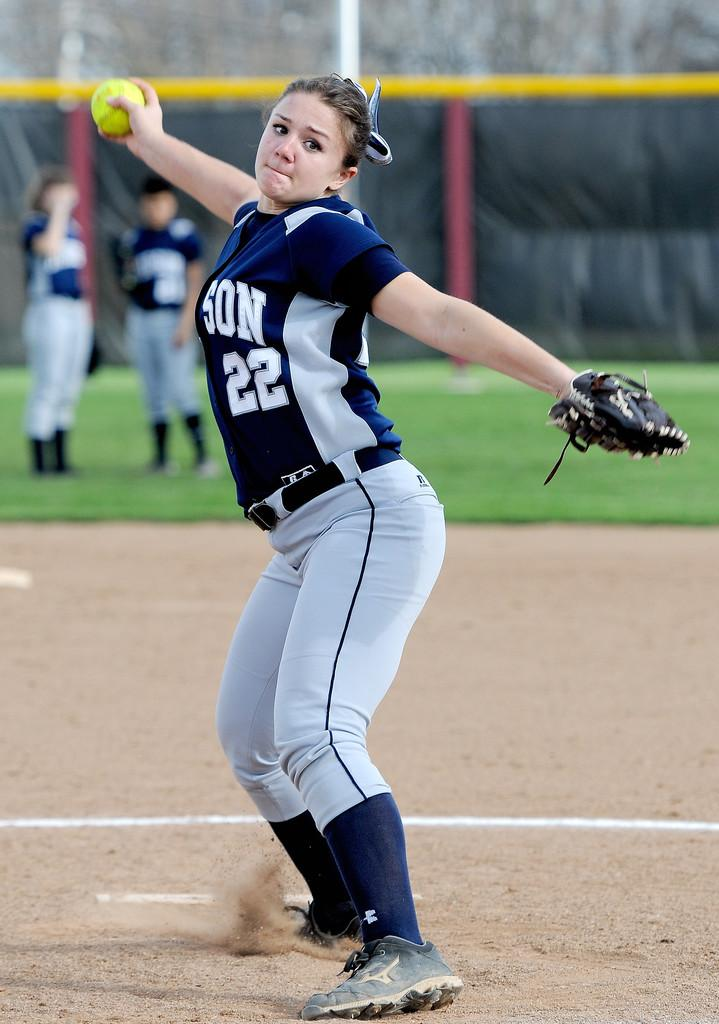<image>
Describe the image concisely. Baseball player wearing number 22 pitching the ball. 